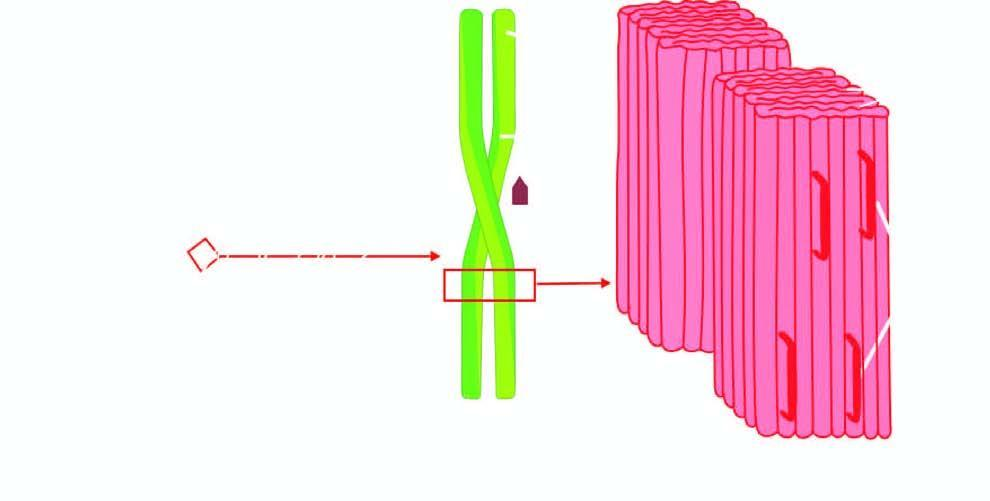what is each fibril further composed of?
Answer the question using a single word or phrase. Double helix of two pleated sheets 